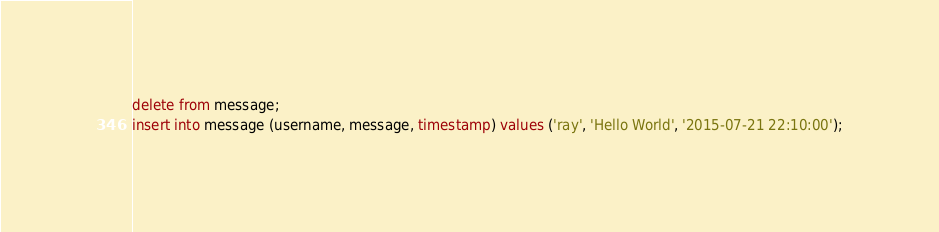Convert code to text. <code><loc_0><loc_0><loc_500><loc_500><_SQL_>delete from message;
insert into message (username, message, timestamp) values ('ray', 'Hello World', '2015-07-21 22:10:00');
</code> 